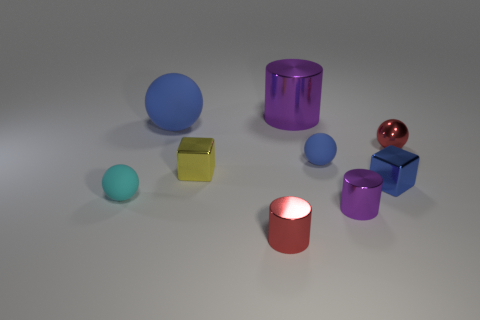Subtract 1 spheres. How many spheres are left? 3 Subtract all red balls. Subtract all gray blocks. How many balls are left? 3 Add 1 large purple metal objects. How many objects exist? 10 Subtract all cubes. How many objects are left? 7 Add 7 blue cubes. How many blue cubes exist? 8 Subtract 0 green balls. How many objects are left? 9 Subtract all blue blocks. Subtract all tiny blue cubes. How many objects are left? 7 Add 8 tiny blue metal blocks. How many tiny blue metal blocks are left? 9 